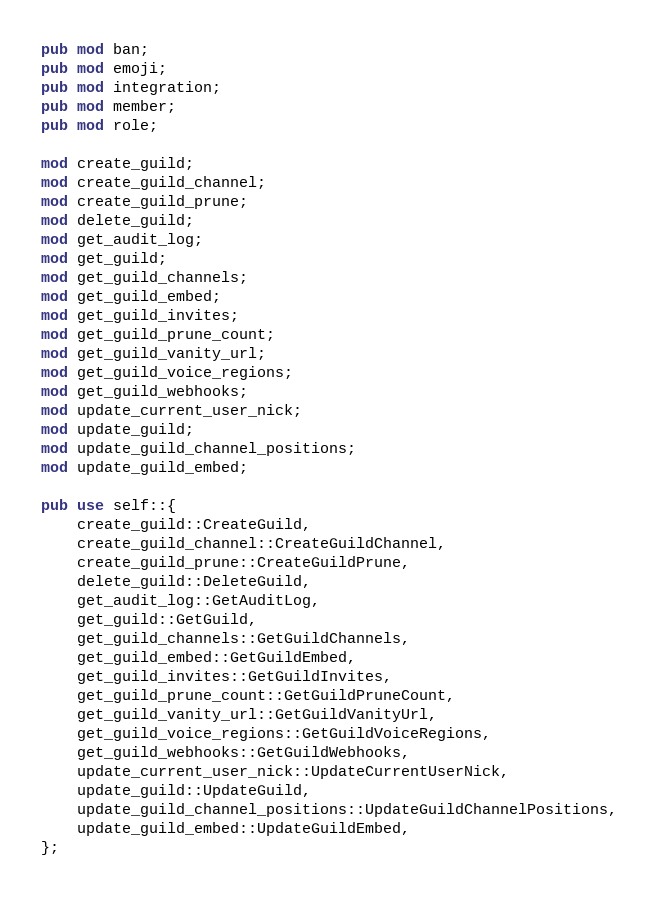<code> <loc_0><loc_0><loc_500><loc_500><_Rust_>pub mod ban;
pub mod emoji;
pub mod integration;
pub mod member;
pub mod role;

mod create_guild;
mod create_guild_channel;
mod create_guild_prune;
mod delete_guild;
mod get_audit_log;
mod get_guild;
mod get_guild_channels;
mod get_guild_embed;
mod get_guild_invites;
mod get_guild_prune_count;
mod get_guild_vanity_url;
mod get_guild_voice_regions;
mod get_guild_webhooks;
mod update_current_user_nick;
mod update_guild;
mod update_guild_channel_positions;
mod update_guild_embed;

pub use self::{
    create_guild::CreateGuild,
    create_guild_channel::CreateGuildChannel,
    create_guild_prune::CreateGuildPrune,
    delete_guild::DeleteGuild,
    get_audit_log::GetAuditLog,
    get_guild::GetGuild,
    get_guild_channels::GetGuildChannels,
    get_guild_embed::GetGuildEmbed,
    get_guild_invites::GetGuildInvites,
    get_guild_prune_count::GetGuildPruneCount,
    get_guild_vanity_url::GetGuildVanityUrl,
    get_guild_voice_regions::GetGuildVoiceRegions,
    get_guild_webhooks::GetGuildWebhooks,
    update_current_user_nick::UpdateCurrentUserNick,
    update_guild::UpdateGuild,
    update_guild_channel_positions::UpdateGuildChannelPositions,
    update_guild_embed::UpdateGuildEmbed,
};
</code> 